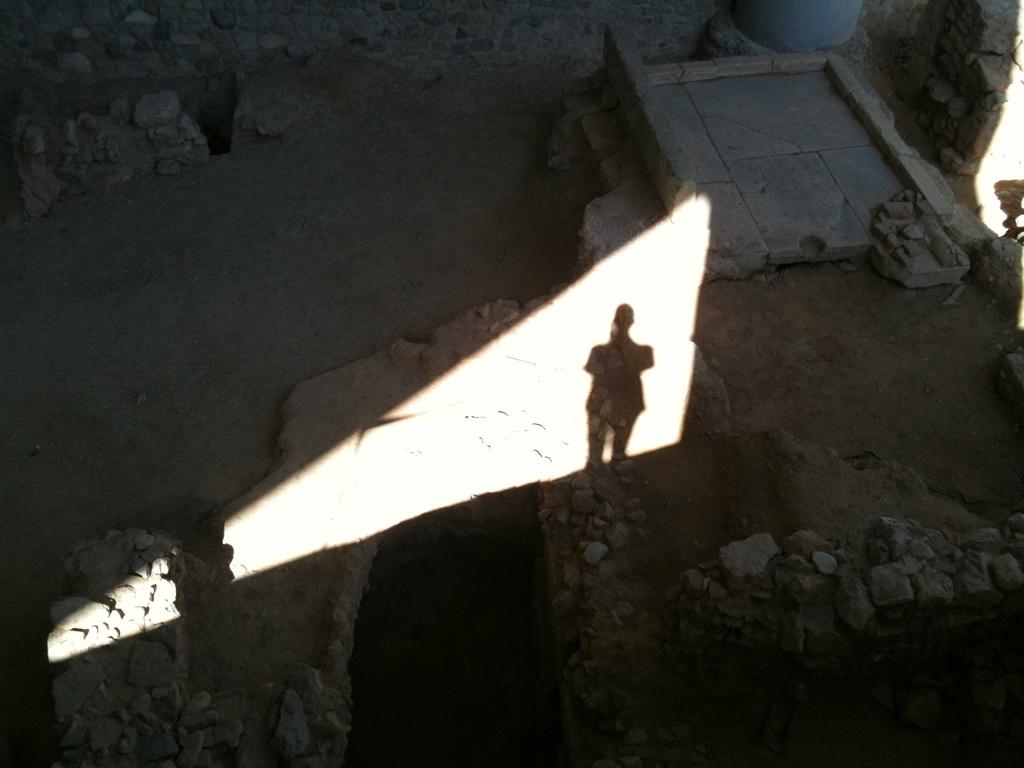What type of objects can be seen on the ground in the image? There are stones on the ground in the image. Can you describe any other features in the image? Yes, there is a shadow of a person in the center of the image. How does the mountain compare to the sea in the image? There is no mountain or sea present in the image; it only features stones on the ground and a shadow of a person. 